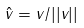Convert formula to latex. <formula><loc_0><loc_0><loc_500><loc_500>\hat { v } = v / | | v | |</formula> 